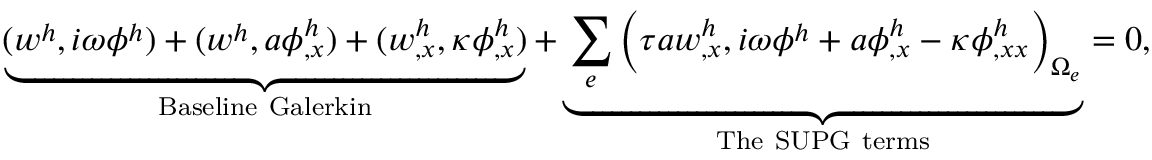Convert formula to latex. <formula><loc_0><loc_0><loc_500><loc_500>\underbrace { ( w ^ { h } , i \omega \phi ^ { h } ) + ( w ^ { h } , a \phi _ { , x } ^ { h } ) + ( w _ { , x } ^ { h } , \kappa \phi _ { , x } ^ { h } ) } _ { B a s e l i n e G a l e r k i n } + \underbrace { \sum _ { e } \left ( \tau a w _ { , x } ^ { h } , i \omega \phi ^ { h } + a \phi _ { , x } ^ { h } - \kappa \phi _ { , x x } ^ { h } \right ) _ { \Omega _ { e } } } _ { T h e S U P G t e r m s } = 0 ,</formula> 